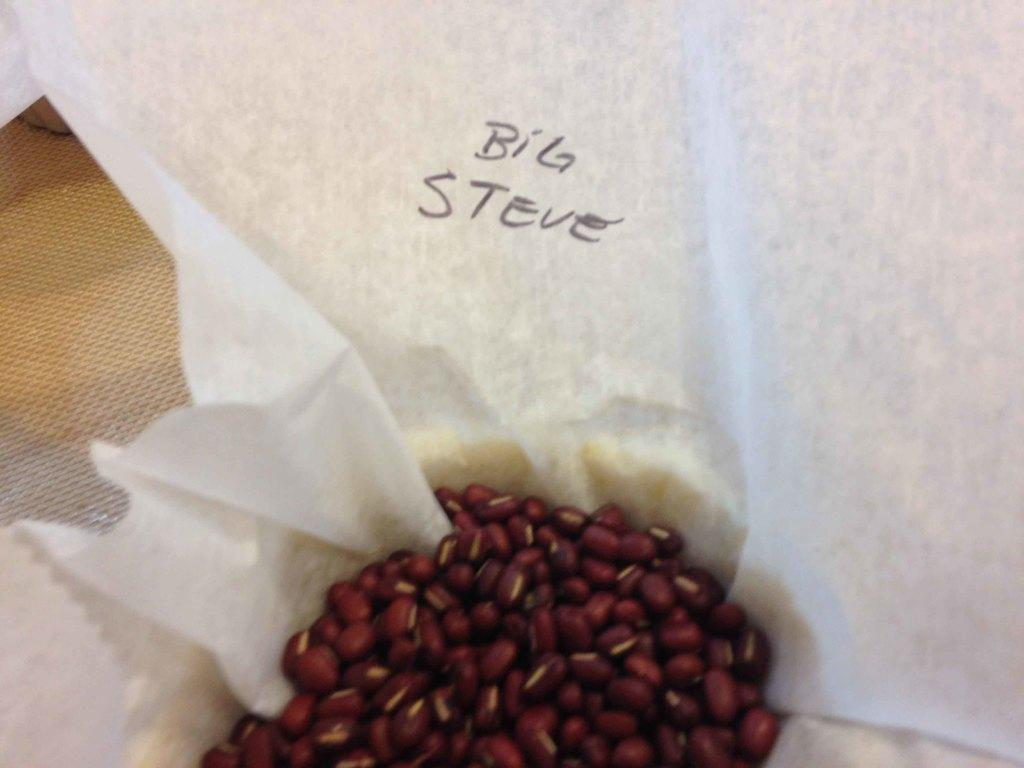What is the main object in the image? There is a white tissue in the image. What other items can be seen in the image? There are red color seeds in the image. What color is the background of the image? The background of the image is brown. Can you tell me how many actors are present in the image? There are no actors present in the image; it features a white tissue and red color seeds against a brown background. 